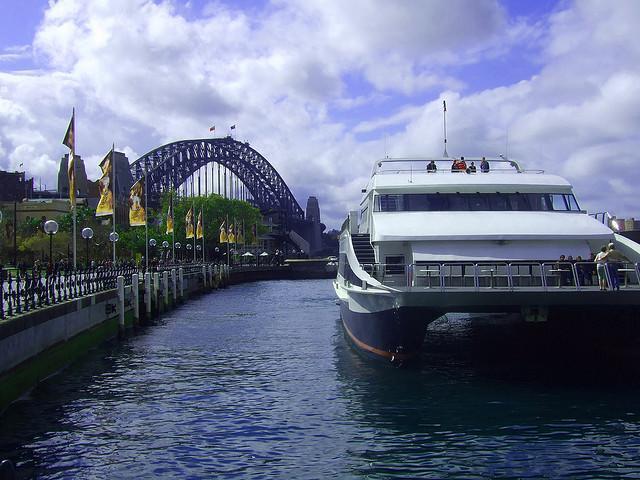Why the gap underneath the boat?
From the following set of four choices, select the accurate answer to respond to the question.
Options: Stability, speed, style, weight reduction. Stability. 